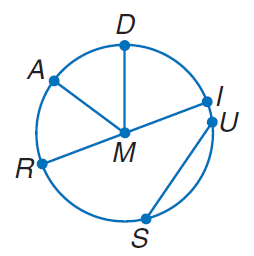Question: If M D = 7, find R I.
Choices:
A. 7
B. 14
C. 21
D. 28
Answer with the letter. Answer: B 